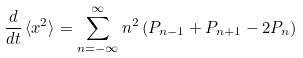Convert formula to latex. <formula><loc_0><loc_0><loc_500><loc_500>\frac { d } { d t } \, \langle x ^ { 2 } \rangle = \sum _ { n = - \infty } ^ { \infty } n ^ { 2 } \left ( P _ { n - 1 } + P _ { n + 1 } - 2 P _ { n } \right )</formula> 